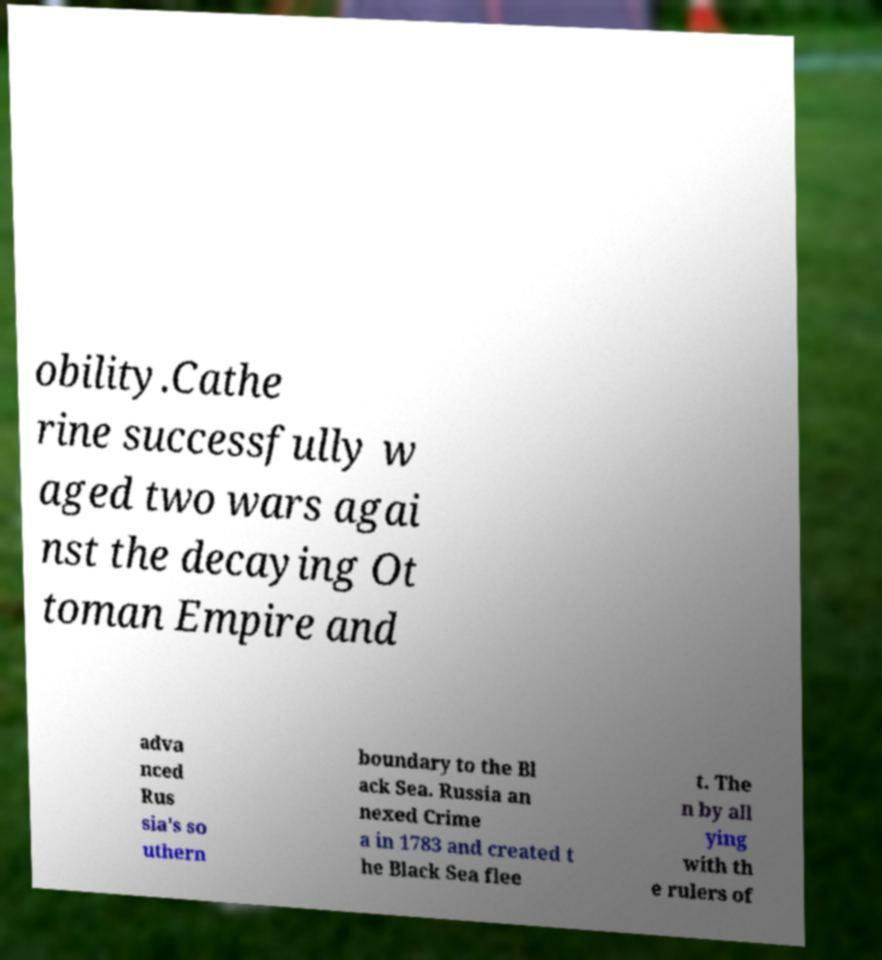Could you extract and type out the text from this image? obility.Cathe rine successfully w aged two wars agai nst the decaying Ot toman Empire and adva nced Rus sia's so uthern boundary to the Bl ack Sea. Russia an nexed Crime a in 1783 and created t he Black Sea flee t. The n by all ying with th e rulers of 